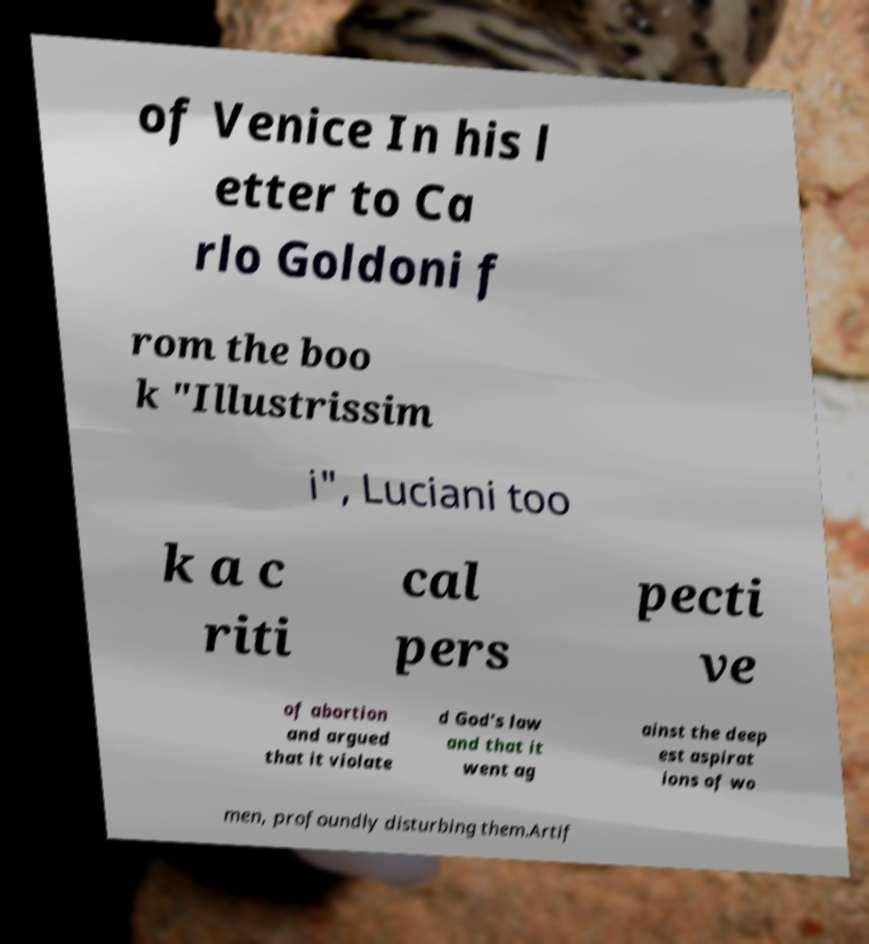Please read and relay the text visible in this image. What does it say? of Venice In his l etter to Ca rlo Goldoni f rom the boo k "Illustrissim i", Luciani too k a c riti cal pers pecti ve of abortion and argued that it violate d God's law and that it went ag ainst the deep est aspirat ions of wo men, profoundly disturbing them.Artif 